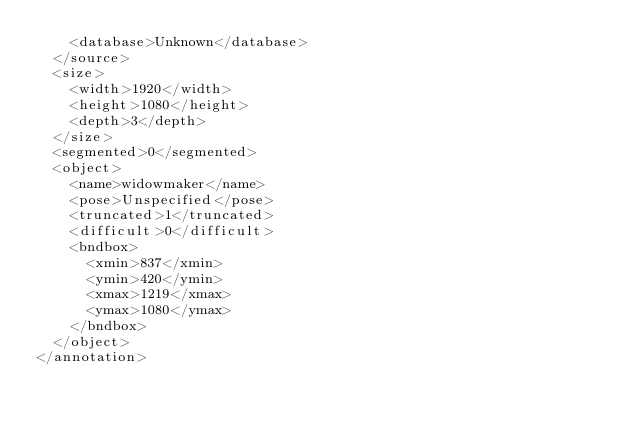Convert code to text. <code><loc_0><loc_0><loc_500><loc_500><_XML_>		<database>Unknown</database>
	</source>
	<size>
		<width>1920</width>
		<height>1080</height>
		<depth>3</depth>
	</size>
	<segmented>0</segmented>
	<object>
		<name>widowmaker</name>
		<pose>Unspecified</pose>
		<truncated>1</truncated>
		<difficult>0</difficult>
		<bndbox>
			<xmin>837</xmin>
			<ymin>420</ymin>
			<xmax>1219</xmax>
			<ymax>1080</ymax>
		</bndbox>
	</object>
</annotation>
</code> 